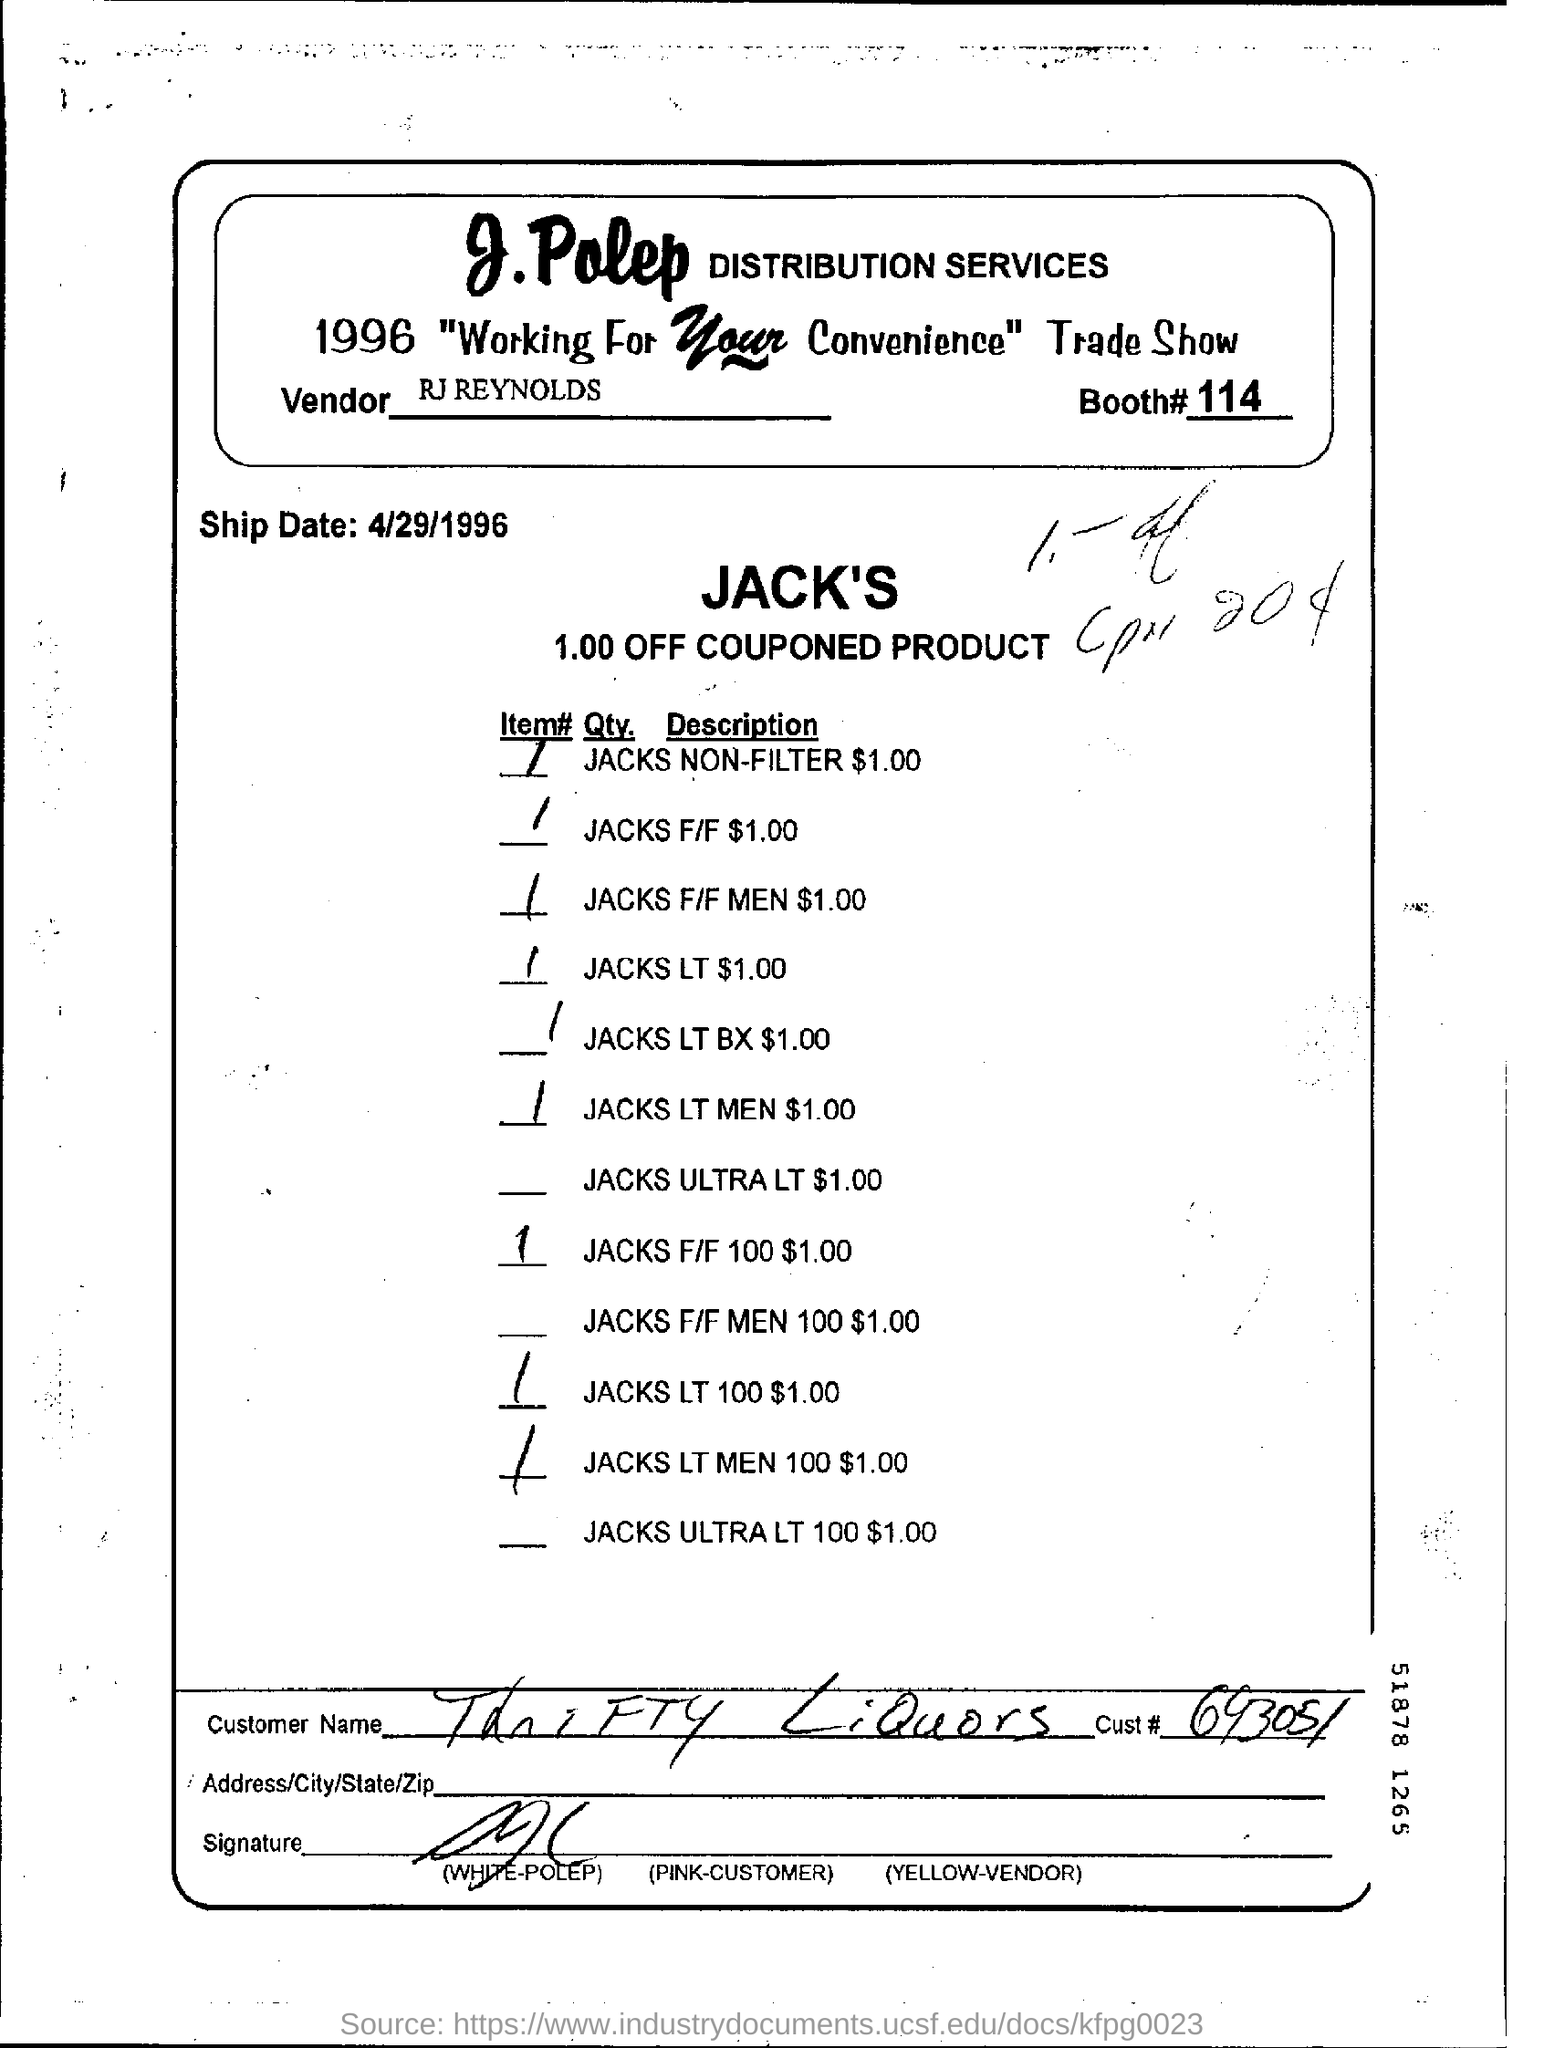Mention a couple of crucial points in this snapshot. I will mention the ship date which is April 29, 1996. Please provide the booth number, 114. The couponed product is currently priced at 1.00. The vendor is RJ Reynolds. 